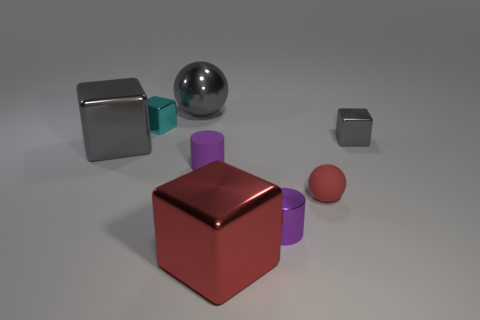Can you tell me the arrangements of objects in relation to each other? Sure, there's a large red cube prominently centered in the image. To the left, there's a medium-sized metallic cube closer to us and a smaller one further back, both also metallic. To the right, there's a large metallic sphere, a cylinder to its right, and a small sphere placed farther away, creating a sense of depth in the composition. 